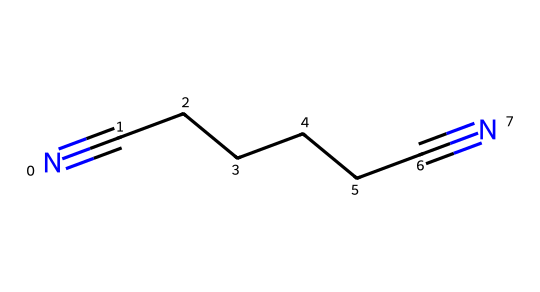What is the molecular formula of adiponitrile? By analyzing the structure provided by the SMILES representation, we can identify that there are a total of 6 carbon atoms and 2 nitrogen atoms. The formula can be constructed from these counts as C6H8N2 (considering the implied hydrogens).
Answer: C6H8N2 How many carbon atoms are present in adiponitrile? The SMILES representation shows a continuous chain of carbon atoms between the two nitrogen atoms. Counting these gives us 6 carbon atoms in total.
Answer: 6 What type of functional groups are present in adiponitrile? The structure features two cyano groups (−C≡N), indicated by the two nitrogen atoms connected to carbon in a triple bond formation, making it a nitrile functional group.
Answer: nitrile How many bonds are between the carbon atoms in adiponitrile? In the given chain of carbon atoms, each adjacent carbon atom is connected by single bonds, giving 5 carbon-carbon single bonds total in a linear structure.
Answer: 5 What is the significance of adiponitrile in industrial applications? Adiponitrile is a key precursor in the production of nylon, which is widely used for durable materials including library book covers, emphasizing its utility in creating strong, resilient polymers.
Answer: nylon What is the hybridization of the carbon atoms in adiponitrile? The carbon atoms in the chain are sp3 hybridized due to the single bonds, while the carbon atoms bonded to the nitrogen in the cyano groups are sp hybridized due to the triple bond structure.
Answer: sp3 and sp 